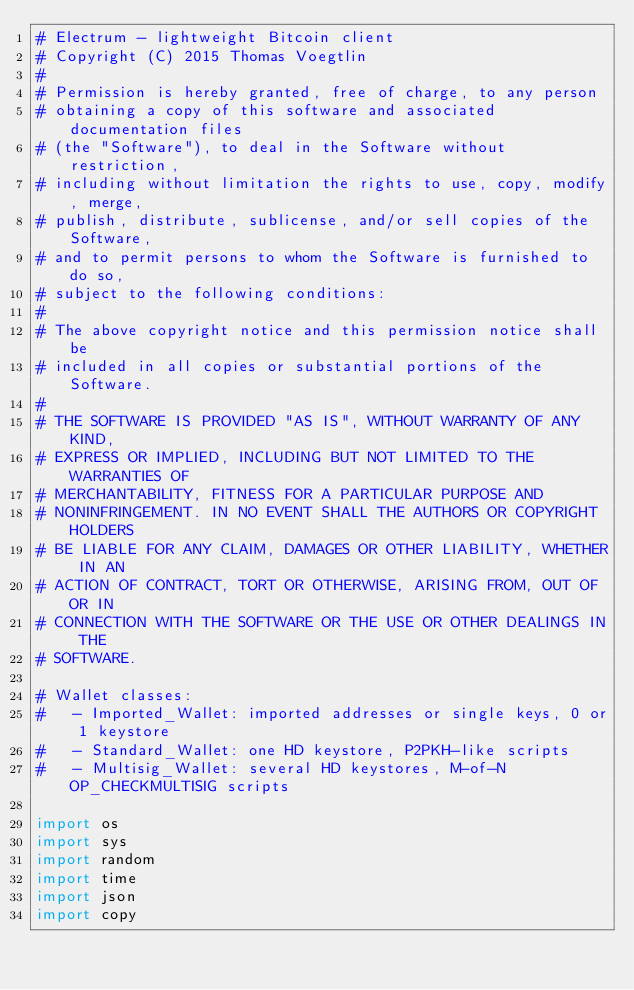<code> <loc_0><loc_0><loc_500><loc_500><_Python_># Electrum - lightweight Bitcoin client
# Copyright (C) 2015 Thomas Voegtlin
#
# Permission is hereby granted, free of charge, to any person
# obtaining a copy of this software and associated documentation files
# (the "Software"), to deal in the Software without restriction,
# including without limitation the rights to use, copy, modify, merge,
# publish, distribute, sublicense, and/or sell copies of the Software,
# and to permit persons to whom the Software is furnished to do so,
# subject to the following conditions:
#
# The above copyright notice and this permission notice shall be
# included in all copies or substantial portions of the Software.
#
# THE SOFTWARE IS PROVIDED "AS IS", WITHOUT WARRANTY OF ANY KIND,
# EXPRESS OR IMPLIED, INCLUDING BUT NOT LIMITED TO THE WARRANTIES OF
# MERCHANTABILITY, FITNESS FOR A PARTICULAR PURPOSE AND
# NONINFRINGEMENT. IN NO EVENT SHALL THE AUTHORS OR COPYRIGHT HOLDERS
# BE LIABLE FOR ANY CLAIM, DAMAGES OR OTHER LIABILITY, WHETHER IN AN
# ACTION OF CONTRACT, TORT OR OTHERWISE, ARISING FROM, OUT OF OR IN
# CONNECTION WITH THE SOFTWARE OR THE USE OR OTHER DEALINGS IN THE
# SOFTWARE.

# Wallet classes:
#   - Imported_Wallet: imported addresses or single keys, 0 or 1 keystore
#   - Standard_Wallet: one HD keystore, P2PKH-like scripts
#   - Multisig_Wallet: several HD keystores, M-of-N OP_CHECKMULTISIG scripts

import os
import sys
import random
import time
import json
import copy</code> 